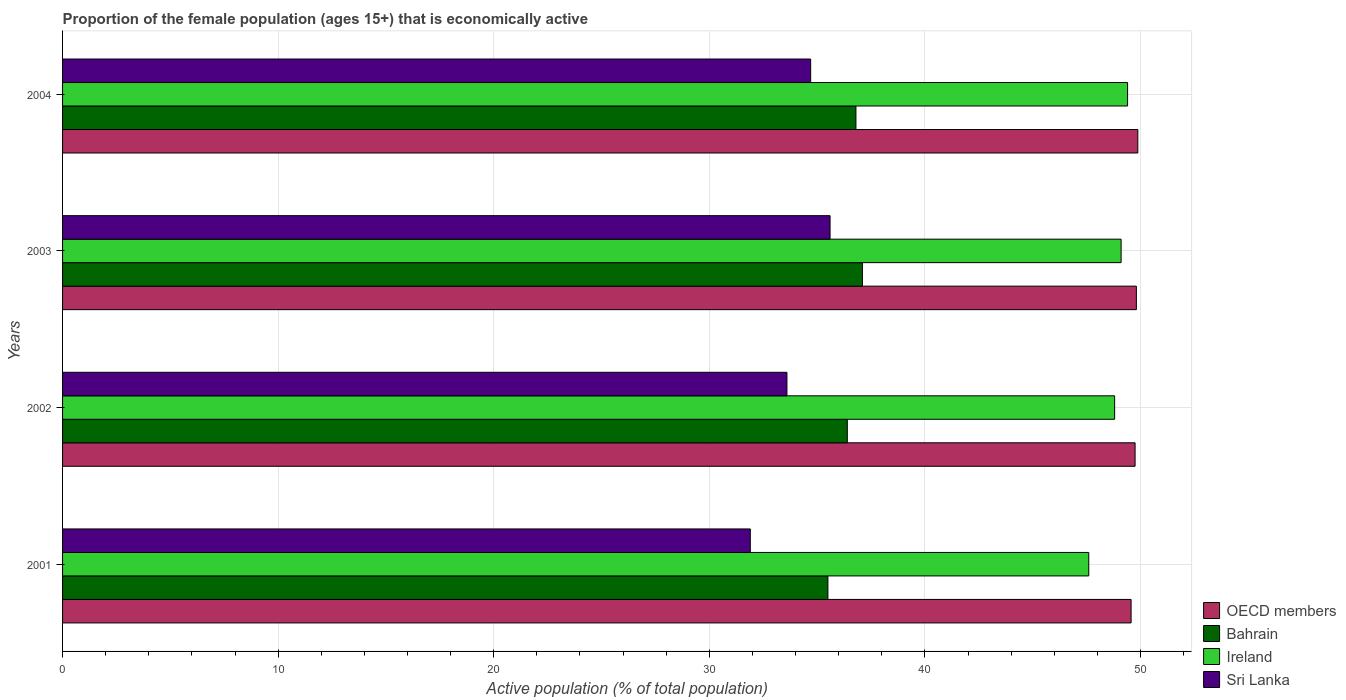How many different coloured bars are there?
Give a very brief answer. 4. How many groups of bars are there?
Offer a very short reply. 4. Are the number of bars on each tick of the Y-axis equal?
Offer a terse response. Yes. How many bars are there on the 2nd tick from the bottom?
Your answer should be compact. 4. What is the proportion of the female population that is economically active in Sri Lanka in 2003?
Keep it short and to the point. 35.6. Across all years, what is the maximum proportion of the female population that is economically active in Sri Lanka?
Offer a terse response. 35.6. Across all years, what is the minimum proportion of the female population that is economically active in OECD members?
Your answer should be compact. 49.56. In which year was the proportion of the female population that is economically active in Bahrain minimum?
Ensure brevity in your answer.  2001. What is the total proportion of the female population that is economically active in OECD members in the graph?
Your response must be concise. 198.99. What is the difference between the proportion of the female population that is economically active in OECD members in 2001 and that in 2004?
Offer a very short reply. -0.31. What is the difference between the proportion of the female population that is economically active in OECD members in 2004 and the proportion of the female population that is economically active in Bahrain in 2003?
Provide a short and direct response. 12.78. What is the average proportion of the female population that is economically active in Sri Lanka per year?
Offer a very short reply. 33.95. In the year 2002, what is the difference between the proportion of the female population that is economically active in OECD members and proportion of the female population that is economically active in Sri Lanka?
Ensure brevity in your answer.  16.15. In how many years, is the proportion of the female population that is economically active in Ireland greater than 6 %?
Your response must be concise. 4. What is the ratio of the proportion of the female population that is economically active in Ireland in 2001 to that in 2004?
Ensure brevity in your answer.  0.96. What is the difference between the highest and the second highest proportion of the female population that is economically active in Sri Lanka?
Offer a terse response. 0.9. What is the difference between the highest and the lowest proportion of the female population that is economically active in Sri Lanka?
Provide a short and direct response. 3.7. What does the 3rd bar from the bottom in 2003 represents?
Provide a short and direct response. Ireland. Is it the case that in every year, the sum of the proportion of the female population that is economically active in Sri Lanka and proportion of the female population that is economically active in OECD members is greater than the proportion of the female population that is economically active in Bahrain?
Provide a succinct answer. Yes. How many bars are there?
Provide a short and direct response. 16. How many years are there in the graph?
Your answer should be very brief. 4. What is the difference between two consecutive major ticks on the X-axis?
Your response must be concise. 10. Does the graph contain any zero values?
Offer a terse response. No. Does the graph contain grids?
Offer a terse response. Yes. How many legend labels are there?
Provide a short and direct response. 4. What is the title of the graph?
Your response must be concise. Proportion of the female population (ages 15+) that is economically active. Does "Philippines" appear as one of the legend labels in the graph?
Keep it short and to the point. No. What is the label or title of the X-axis?
Offer a very short reply. Active population (% of total population). What is the Active population (% of total population) in OECD members in 2001?
Keep it short and to the point. 49.56. What is the Active population (% of total population) of Bahrain in 2001?
Your answer should be very brief. 35.5. What is the Active population (% of total population) in Ireland in 2001?
Offer a very short reply. 47.6. What is the Active population (% of total population) in Sri Lanka in 2001?
Keep it short and to the point. 31.9. What is the Active population (% of total population) in OECD members in 2002?
Your answer should be compact. 49.75. What is the Active population (% of total population) in Bahrain in 2002?
Provide a short and direct response. 36.4. What is the Active population (% of total population) in Ireland in 2002?
Your answer should be compact. 48.8. What is the Active population (% of total population) of Sri Lanka in 2002?
Offer a very short reply. 33.6. What is the Active population (% of total population) of OECD members in 2003?
Offer a very short reply. 49.81. What is the Active population (% of total population) of Bahrain in 2003?
Your response must be concise. 37.1. What is the Active population (% of total population) in Ireland in 2003?
Provide a short and direct response. 49.1. What is the Active population (% of total population) in Sri Lanka in 2003?
Give a very brief answer. 35.6. What is the Active population (% of total population) in OECD members in 2004?
Your response must be concise. 49.88. What is the Active population (% of total population) in Bahrain in 2004?
Provide a succinct answer. 36.8. What is the Active population (% of total population) in Ireland in 2004?
Provide a short and direct response. 49.4. What is the Active population (% of total population) of Sri Lanka in 2004?
Your answer should be very brief. 34.7. Across all years, what is the maximum Active population (% of total population) in OECD members?
Your answer should be compact. 49.88. Across all years, what is the maximum Active population (% of total population) of Bahrain?
Give a very brief answer. 37.1. Across all years, what is the maximum Active population (% of total population) in Ireland?
Keep it short and to the point. 49.4. Across all years, what is the maximum Active population (% of total population) of Sri Lanka?
Keep it short and to the point. 35.6. Across all years, what is the minimum Active population (% of total population) of OECD members?
Offer a very short reply. 49.56. Across all years, what is the minimum Active population (% of total population) of Bahrain?
Make the answer very short. 35.5. Across all years, what is the minimum Active population (% of total population) in Ireland?
Provide a short and direct response. 47.6. Across all years, what is the minimum Active population (% of total population) of Sri Lanka?
Offer a very short reply. 31.9. What is the total Active population (% of total population) of OECD members in the graph?
Your answer should be compact. 198.99. What is the total Active population (% of total population) in Bahrain in the graph?
Provide a succinct answer. 145.8. What is the total Active population (% of total population) in Ireland in the graph?
Ensure brevity in your answer.  194.9. What is the total Active population (% of total population) of Sri Lanka in the graph?
Your answer should be very brief. 135.8. What is the difference between the Active population (% of total population) in OECD members in 2001 and that in 2002?
Offer a very short reply. -0.19. What is the difference between the Active population (% of total population) of Bahrain in 2001 and that in 2002?
Your response must be concise. -0.9. What is the difference between the Active population (% of total population) of Sri Lanka in 2001 and that in 2002?
Keep it short and to the point. -1.7. What is the difference between the Active population (% of total population) of OECD members in 2001 and that in 2003?
Your response must be concise. -0.24. What is the difference between the Active population (% of total population) of Sri Lanka in 2001 and that in 2003?
Your answer should be compact. -3.7. What is the difference between the Active population (% of total population) of OECD members in 2001 and that in 2004?
Keep it short and to the point. -0.31. What is the difference between the Active population (% of total population) of Sri Lanka in 2001 and that in 2004?
Make the answer very short. -2.8. What is the difference between the Active population (% of total population) in OECD members in 2002 and that in 2003?
Give a very brief answer. -0.06. What is the difference between the Active population (% of total population) in Bahrain in 2002 and that in 2003?
Keep it short and to the point. -0.7. What is the difference between the Active population (% of total population) in Ireland in 2002 and that in 2003?
Make the answer very short. -0.3. What is the difference between the Active population (% of total population) of OECD members in 2002 and that in 2004?
Ensure brevity in your answer.  -0.13. What is the difference between the Active population (% of total population) in Bahrain in 2002 and that in 2004?
Your response must be concise. -0.4. What is the difference between the Active population (% of total population) in Sri Lanka in 2002 and that in 2004?
Provide a succinct answer. -1.1. What is the difference between the Active population (% of total population) of OECD members in 2003 and that in 2004?
Provide a succinct answer. -0.07. What is the difference between the Active population (% of total population) of Bahrain in 2003 and that in 2004?
Offer a terse response. 0.3. What is the difference between the Active population (% of total population) in Ireland in 2003 and that in 2004?
Your answer should be very brief. -0.3. What is the difference between the Active population (% of total population) in OECD members in 2001 and the Active population (% of total population) in Bahrain in 2002?
Your answer should be compact. 13.16. What is the difference between the Active population (% of total population) in OECD members in 2001 and the Active population (% of total population) in Ireland in 2002?
Your answer should be very brief. 0.76. What is the difference between the Active population (% of total population) in OECD members in 2001 and the Active population (% of total population) in Sri Lanka in 2002?
Make the answer very short. 15.96. What is the difference between the Active population (% of total population) of Bahrain in 2001 and the Active population (% of total population) of Sri Lanka in 2002?
Your answer should be compact. 1.9. What is the difference between the Active population (% of total population) of OECD members in 2001 and the Active population (% of total population) of Bahrain in 2003?
Provide a short and direct response. 12.46. What is the difference between the Active population (% of total population) of OECD members in 2001 and the Active population (% of total population) of Ireland in 2003?
Give a very brief answer. 0.46. What is the difference between the Active population (% of total population) of OECD members in 2001 and the Active population (% of total population) of Sri Lanka in 2003?
Provide a short and direct response. 13.96. What is the difference between the Active population (% of total population) of Bahrain in 2001 and the Active population (% of total population) of Sri Lanka in 2003?
Make the answer very short. -0.1. What is the difference between the Active population (% of total population) in OECD members in 2001 and the Active population (% of total population) in Bahrain in 2004?
Keep it short and to the point. 12.76. What is the difference between the Active population (% of total population) in OECD members in 2001 and the Active population (% of total population) in Ireland in 2004?
Your response must be concise. 0.16. What is the difference between the Active population (% of total population) in OECD members in 2001 and the Active population (% of total population) in Sri Lanka in 2004?
Offer a terse response. 14.86. What is the difference between the Active population (% of total population) in Bahrain in 2001 and the Active population (% of total population) in Sri Lanka in 2004?
Make the answer very short. 0.8. What is the difference between the Active population (% of total population) in OECD members in 2002 and the Active population (% of total population) in Bahrain in 2003?
Your answer should be very brief. 12.65. What is the difference between the Active population (% of total population) of OECD members in 2002 and the Active population (% of total population) of Ireland in 2003?
Ensure brevity in your answer.  0.65. What is the difference between the Active population (% of total population) in OECD members in 2002 and the Active population (% of total population) in Sri Lanka in 2003?
Keep it short and to the point. 14.15. What is the difference between the Active population (% of total population) of Bahrain in 2002 and the Active population (% of total population) of Ireland in 2003?
Give a very brief answer. -12.7. What is the difference between the Active population (% of total population) in Bahrain in 2002 and the Active population (% of total population) in Sri Lanka in 2003?
Your answer should be very brief. 0.8. What is the difference between the Active population (% of total population) in Ireland in 2002 and the Active population (% of total population) in Sri Lanka in 2003?
Provide a short and direct response. 13.2. What is the difference between the Active population (% of total population) of OECD members in 2002 and the Active population (% of total population) of Bahrain in 2004?
Make the answer very short. 12.95. What is the difference between the Active population (% of total population) in OECD members in 2002 and the Active population (% of total population) in Ireland in 2004?
Provide a short and direct response. 0.35. What is the difference between the Active population (% of total population) in OECD members in 2002 and the Active population (% of total population) in Sri Lanka in 2004?
Your answer should be compact. 15.05. What is the difference between the Active population (% of total population) in Bahrain in 2002 and the Active population (% of total population) in Sri Lanka in 2004?
Your answer should be very brief. 1.7. What is the difference between the Active population (% of total population) in Ireland in 2002 and the Active population (% of total population) in Sri Lanka in 2004?
Provide a short and direct response. 14.1. What is the difference between the Active population (% of total population) in OECD members in 2003 and the Active population (% of total population) in Bahrain in 2004?
Ensure brevity in your answer.  13.01. What is the difference between the Active population (% of total population) in OECD members in 2003 and the Active population (% of total population) in Ireland in 2004?
Ensure brevity in your answer.  0.41. What is the difference between the Active population (% of total population) in OECD members in 2003 and the Active population (% of total population) in Sri Lanka in 2004?
Provide a succinct answer. 15.11. What is the average Active population (% of total population) of OECD members per year?
Make the answer very short. 49.75. What is the average Active population (% of total population) in Bahrain per year?
Provide a short and direct response. 36.45. What is the average Active population (% of total population) in Ireland per year?
Offer a very short reply. 48.73. What is the average Active population (% of total population) of Sri Lanka per year?
Your answer should be very brief. 33.95. In the year 2001, what is the difference between the Active population (% of total population) in OECD members and Active population (% of total population) in Bahrain?
Keep it short and to the point. 14.06. In the year 2001, what is the difference between the Active population (% of total population) in OECD members and Active population (% of total population) in Ireland?
Your response must be concise. 1.96. In the year 2001, what is the difference between the Active population (% of total population) in OECD members and Active population (% of total population) in Sri Lanka?
Provide a short and direct response. 17.66. In the year 2001, what is the difference between the Active population (% of total population) of Ireland and Active population (% of total population) of Sri Lanka?
Keep it short and to the point. 15.7. In the year 2002, what is the difference between the Active population (% of total population) in OECD members and Active population (% of total population) in Bahrain?
Provide a succinct answer. 13.35. In the year 2002, what is the difference between the Active population (% of total population) in OECD members and Active population (% of total population) in Ireland?
Your answer should be compact. 0.95. In the year 2002, what is the difference between the Active population (% of total population) of OECD members and Active population (% of total population) of Sri Lanka?
Your answer should be compact. 16.15. In the year 2002, what is the difference between the Active population (% of total population) of Ireland and Active population (% of total population) of Sri Lanka?
Your response must be concise. 15.2. In the year 2003, what is the difference between the Active population (% of total population) of OECD members and Active population (% of total population) of Bahrain?
Make the answer very short. 12.71. In the year 2003, what is the difference between the Active population (% of total population) in OECD members and Active population (% of total population) in Ireland?
Your response must be concise. 0.71. In the year 2003, what is the difference between the Active population (% of total population) in OECD members and Active population (% of total population) in Sri Lanka?
Offer a terse response. 14.21. In the year 2003, what is the difference between the Active population (% of total population) of Bahrain and Active population (% of total population) of Ireland?
Your answer should be very brief. -12. In the year 2004, what is the difference between the Active population (% of total population) of OECD members and Active population (% of total population) of Bahrain?
Make the answer very short. 13.08. In the year 2004, what is the difference between the Active population (% of total population) of OECD members and Active population (% of total population) of Ireland?
Provide a short and direct response. 0.48. In the year 2004, what is the difference between the Active population (% of total population) of OECD members and Active population (% of total population) of Sri Lanka?
Provide a succinct answer. 15.18. In the year 2004, what is the difference between the Active population (% of total population) of Bahrain and Active population (% of total population) of Sri Lanka?
Provide a short and direct response. 2.1. What is the ratio of the Active population (% of total population) of Bahrain in 2001 to that in 2002?
Keep it short and to the point. 0.98. What is the ratio of the Active population (% of total population) in Ireland in 2001 to that in 2002?
Give a very brief answer. 0.98. What is the ratio of the Active population (% of total population) of Sri Lanka in 2001 to that in 2002?
Offer a terse response. 0.95. What is the ratio of the Active population (% of total population) of OECD members in 2001 to that in 2003?
Your response must be concise. 1. What is the ratio of the Active population (% of total population) in Bahrain in 2001 to that in 2003?
Provide a short and direct response. 0.96. What is the ratio of the Active population (% of total population) of Ireland in 2001 to that in 2003?
Offer a very short reply. 0.97. What is the ratio of the Active population (% of total population) of Sri Lanka in 2001 to that in 2003?
Provide a short and direct response. 0.9. What is the ratio of the Active population (% of total population) in OECD members in 2001 to that in 2004?
Offer a very short reply. 0.99. What is the ratio of the Active population (% of total population) of Bahrain in 2001 to that in 2004?
Keep it short and to the point. 0.96. What is the ratio of the Active population (% of total population) of Ireland in 2001 to that in 2004?
Make the answer very short. 0.96. What is the ratio of the Active population (% of total population) in Sri Lanka in 2001 to that in 2004?
Your response must be concise. 0.92. What is the ratio of the Active population (% of total population) of Bahrain in 2002 to that in 2003?
Ensure brevity in your answer.  0.98. What is the ratio of the Active population (% of total population) in Ireland in 2002 to that in 2003?
Offer a terse response. 0.99. What is the ratio of the Active population (% of total population) in Sri Lanka in 2002 to that in 2003?
Give a very brief answer. 0.94. What is the ratio of the Active population (% of total population) of Ireland in 2002 to that in 2004?
Give a very brief answer. 0.99. What is the ratio of the Active population (% of total population) of Sri Lanka in 2002 to that in 2004?
Make the answer very short. 0.97. What is the ratio of the Active population (% of total population) in Bahrain in 2003 to that in 2004?
Provide a succinct answer. 1.01. What is the ratio of the Active population (% of total population) of Ireland in 2003 to that in 2004?
Keep it short and to the point. 0.99. What is the ratio of the Active population (% of total population) in Sri Lanka in 2003 to that in 2004?
Offer a terse response. 1.03. What is the difference between the highest and the second highest Active population (% of total population) of OECD members?
Your answer should be very brief. 0.07. What is the difference between the highest and the second highest Active population (% of total population) in Ireland?
Your response must be concise. 0.3. What is the difference between the highest and the second highest Active population (% of total population) in Sri Lanka?
Keep it short and to the point. 0.9. What is the difference between the highest and the lowest Active population (% of total population) of OECD members?
Make the answer very short. 0.31. 